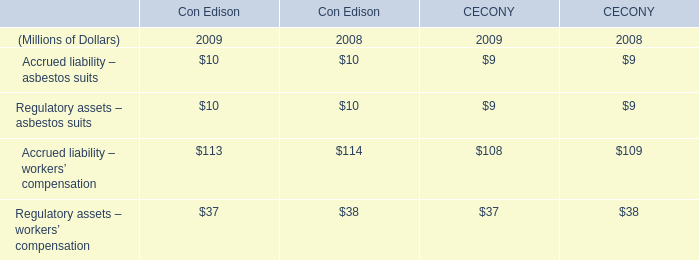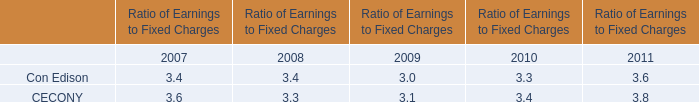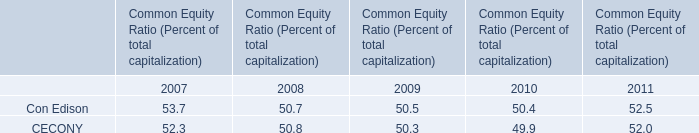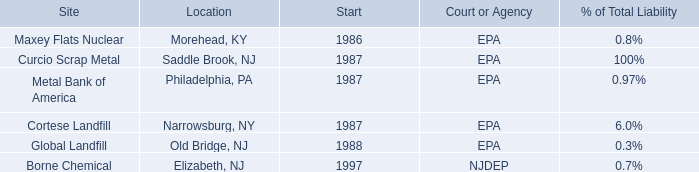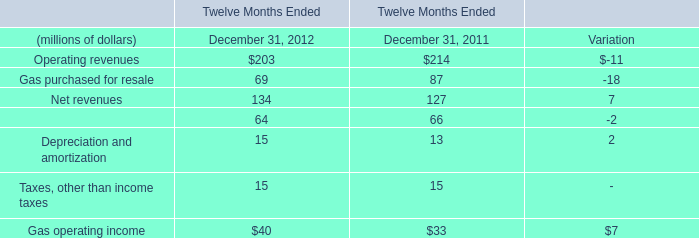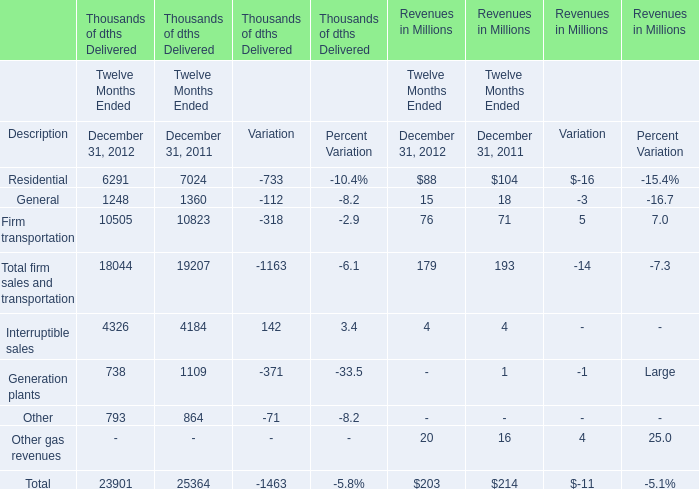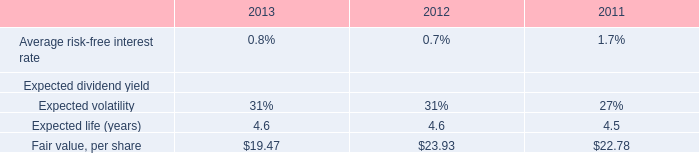What's the growth rate of Firm transportation in Revenues in Millions in 2012? 
Computations: ((76 - 71) / 71)
Answer: 0.07042. 